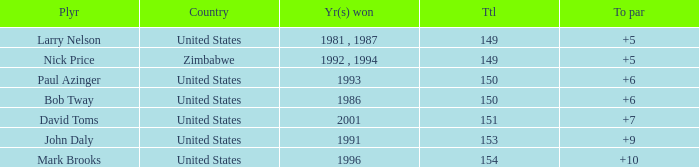How many to pars were won in 1993? 1.0. 